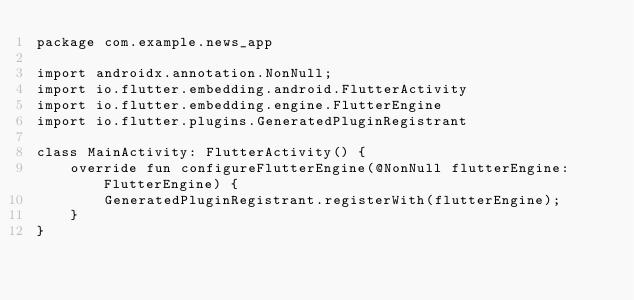Convert code to text. <code><loc_0><loc_0><loc_500><loc_500><_Kotlin_>package com.example.news_app

import androidx.annotation.NonNull;
import io.flutter.embedding.android.FlutterActivity
import io.flutter.embedding.engine.FlutterEngine
import io.flutter.plugins.GeneratedPluginRegistrant

class MainActivity: FlutterActivity() {
    override fun configureFlutterEngine(@NonNull flutterEngine: FlutterEngine) {
        GeneratedPluginRegistrant.registerWith(flutterEngine);
    }
}
</code> 